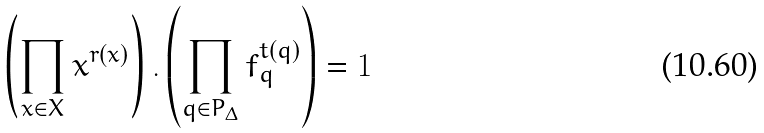<formula> <loc_0><loc_0><loc_500><loc_500>\left ( \prod _ { x \in X } x ^ { r ( x ) } \right ) . \left ( \prod _ { q \in P _ { \Delta } } f _ { q } ^ { t ( q ) } \right ) = 1</formula> 